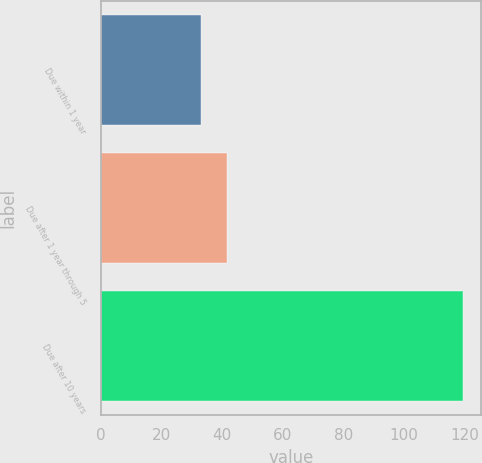Convert chart. <chart><loc_0><loc_0><loc_500><loc_500><bar_chart><fcel>Due within 1 year<fcel>Due after 1 year through 5<fcel>Due after 10 years<nl><fcel>33<fcel>41.64<fcel>119.4<nl></chart> 